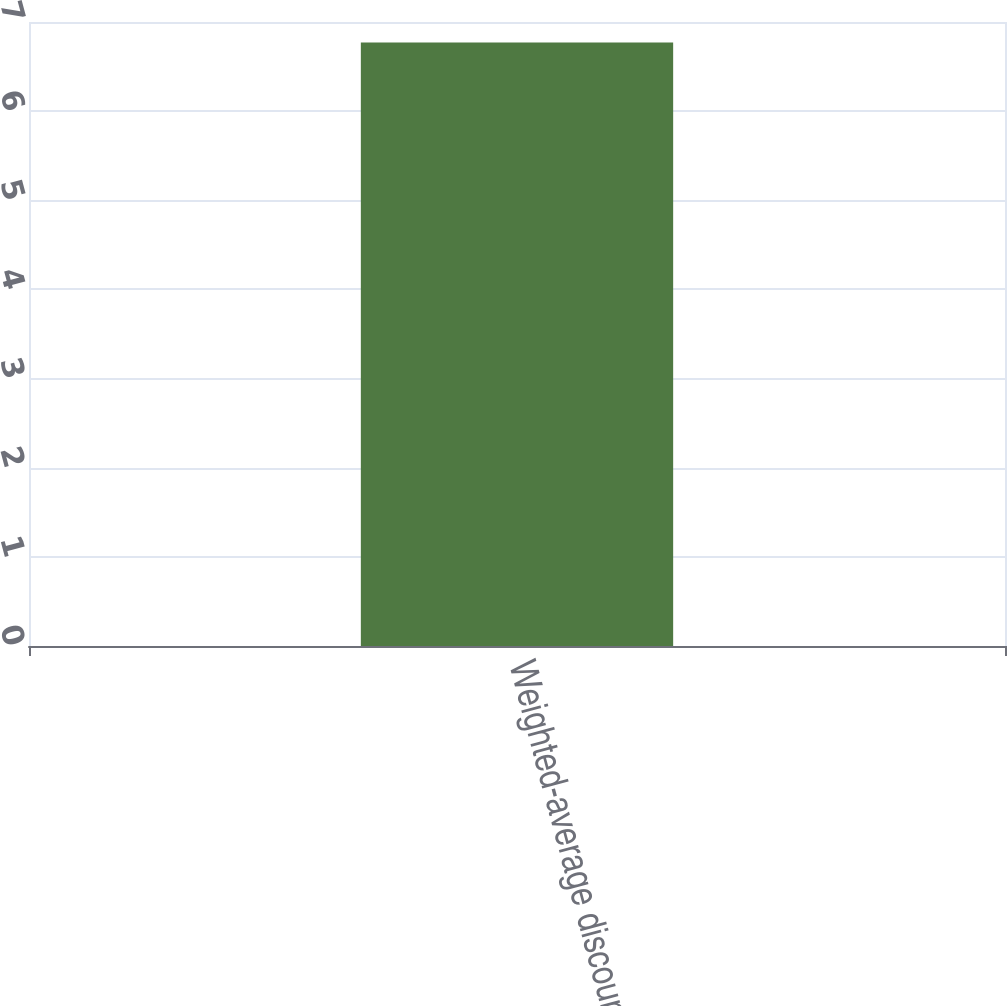Convert chart. <chart><loc_0><loc_0><loc_500><loc_500><bar_chart><fcel>Weighted-average discount rate<nl><fcel>6.77<nl></chart> 